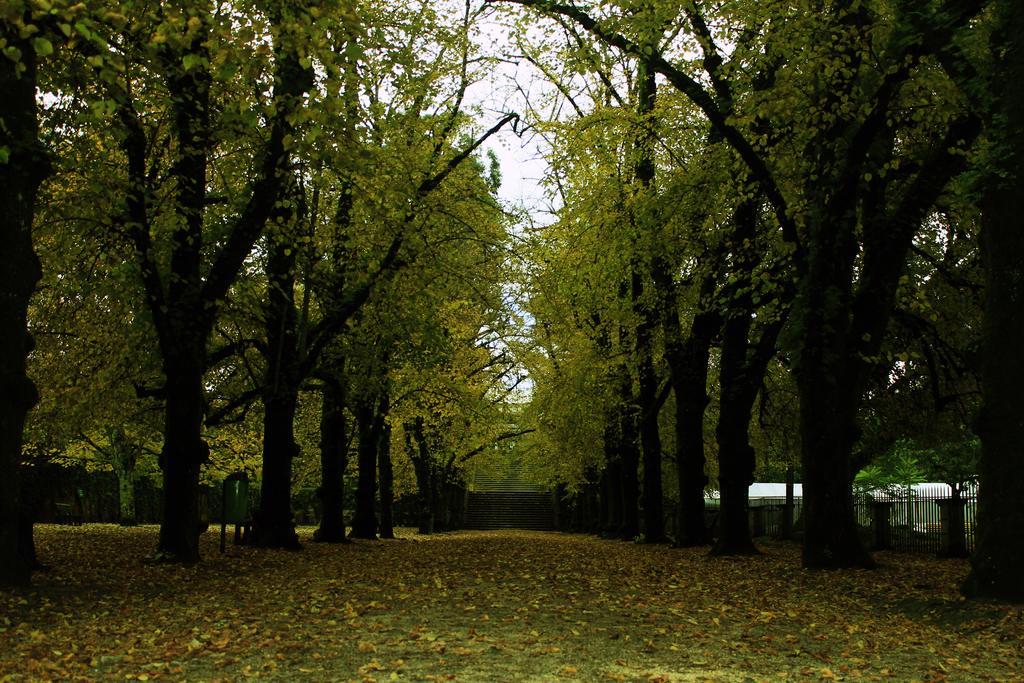Describe this image in one or two sentences. In this image there are trees inside a wooden fence, on the surface there are dry leaves. 